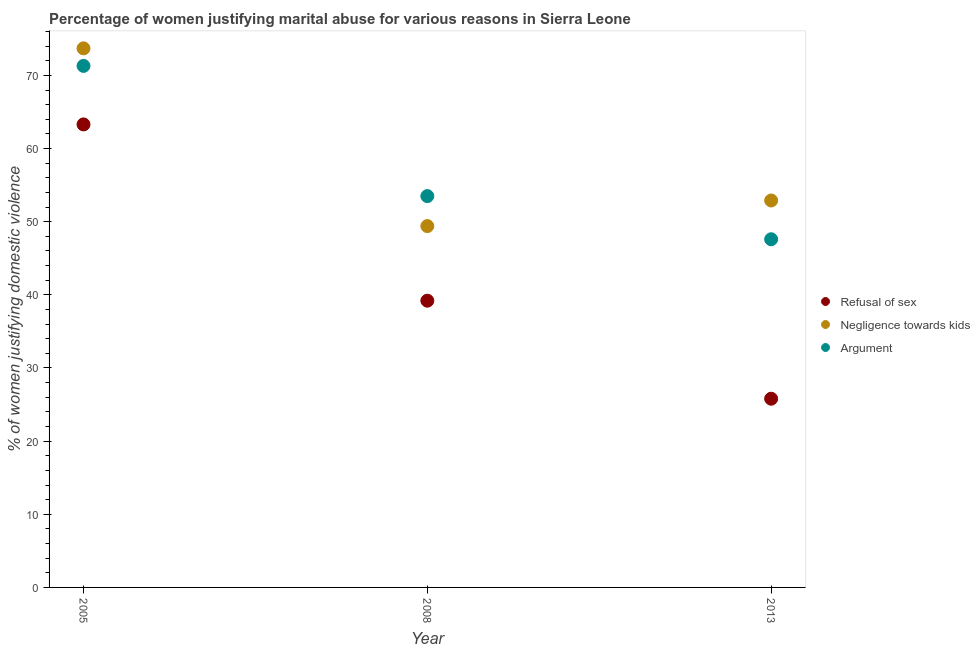How many different coloured dotlines are there?
Your response must be concise. 3. What is the percentage of women justifying domestic violence due to negligence towards kids in 2008?
Your answer should be very brief. 49.4. Across all years, what is the maximum percentage of women justifying domestic violence due to arguments?
Your answer should be very brief. 71.3. Across all years, what is the minimum percentage of women justifying domestic violence due to negligence towards kids?
Provide a succinct answer. 49.4. What is the total percentage of women justifying domestic violence due to negligence towards kids in the graph?
Your response must be concise. 176. What is the difference between the percentage of women justifying domestic violence due to refusal of sex in 2005 and that in 2013?
Your answer should be very brief. 37.5. What is the difference between the percentage of women justifying domestic violence due to negligence towards kids in 2013 and the percentage of women justifying domestic violence due to arguments in 2008?
Offer a terse response. -0.6. What is the average percentage of women justifying domestic violence due to arguments per year?
Keep it short and to the point. 57.47. In the year 2008, what is the difference between the percentage of women justifying domestic violence due to refusal of sex and percentage of women justifying domestic violence due to arguments?
Ensure brevity in your answer.  -14.3. What is the ratio of the percentage of women justifying domestic violence due to refusal of sex in 2005 to that in 2013?
Offer a terse response. 2.45. Is the percentage of women justifying domestic violence due to refusal of sex in 2005 less than that in 2013?
Your answer should be compact. No. What is the difference between the highest and the second highest percentage of women justifying domestic violence due to negligence towards kids?
Give a very brief answer. 20.8. What is the difference between the highest and the lowest percentage of women justifying domestic violence due to negligence towards kids?
Give a very brief answer. 24.3. In how many years, is the percentage of women justifying domestic violence due to negligence towards kids greater than the average percentage of women justifying domestic violence due to negligence towards kids taken over all years?
Keep it short and to the point. 1. Is the sum of the percentage of women justifying domestic violence due to arguments in 2005 and 2013 greater than the maximum percentage of women justifying domestic violence due to negligence towards kids across all years?
Your answer should be very brief. Yes. Is it the case that in every year, the sum of the percentage of women justifying domestic violence due to refusal of sex and percentage of women justifying domestic violence due to negligence towards kids is greater than the percentage of women justifying domestic violence due to arguments?
Offer a very short reply. Yes. Is the percentage of women justifying domestic violence due to refusal of sex strictly greater than the percentage of women justifying domestic violence due to arguments over the years?
Ensure brevity in your answer.  No. Is the percentage of women justifying domestic violence due to arguments strictly less than the percentage of women justifying domestic violence due to negligence towards kids over the years?
Ensure brevity in your answer.  No. How many dotlines are there?
Offer a terse response. 3. What is the difference between two consecutive major ticks on the Y-axis?
Make the answer very short. 10. Are the values on the major ticks of Y-axis written in scientific E-notation?
Make the answer very short. No. Does the graph contain any zero values?
Keep it short and to the point. No. Does the graph contain grids?
Provide a short and direct response. No. Where does the legend appear in the graph?
Your answer should be compact. Center right. How are the legend labels stacked?
Keep it short and to the point. Vertical. What is the title of the graph?
Your answer should be very brief. Percentage of women justifying marital abuse for various reasons in Sierra Leone. Does "Taxes on income" appear as one of the legend labels in the graph?
Provide a succinct answer. No. What is the label or title of the X-axis?
Offer a very short reply. Year. What is the label or title of the Y-axis?
Give a very brief answer. % of women justifying domestic violence. What is the % of women justifying domestic violence in Refusal of sex in 2005?
Provide a succinct answer. 63.3. What is the % of women justifying domestic violence of Negligence towards kids in 2005?
Your answer should be compact. 73.7. What is the % of women justifying domestic violence of Argument in 2005?
Your response must be concise. 71.3. What is the % of women justifying domestic violence in Refusal of sex in 2008?
Your response must be concise. 39.2. What is the % of women justifying domestic violence in Negligence towards kids in 2008?
Offer a terse response. 49.4. What is the % of women justifying domestic violence of Argument in 2008?
Offer a very short reply. 53.5. What is the % of women justifying domestic violence in Refusal of sex in 2013?
Make the answer very short. 25.8. What is the % of women justifying domestic violence of Negligence towards kids in 2013?
Keep it short and to the point. 52.9. What is the % of women justifying domestic violence of Argument in 2013?
Ensure brevity in your answer.  47.6. Across all years, what is the maximum % of women justifying domestic violence in Refusal of sex?
Your answer should be very brief. 63.3. Across all years, what is the maximum % of women justifying domestic violence in Negligence towards kids?
Keep it short and to the point. 73.7. Across all years, what is the maximum % of women justifying domestic violence in Argument?
Make the answer very short. 71.3. Across all years, what is the minimum % of women justifying domestic violence in Refusal of sex?
Offer a terse response. 25.8. Across all years, what is the minimum % of women justifying domestic violence in Negligence towards kids?
Your response must be concise. 49.4. Across all years, what is the minimum % of women justifying domestic violence of Argument?
Provide a short and direct response. 47.6. What is the total % of women justifying domestic violence of Refusal of sex in the graph?
Your answer should be compact. 128.3. What is the total % of women justifying domestic violence in Negligence towards kids in the graph?
Provide a short and direct response. 176. What is the total % of women justifying domestic violence of Argument in the graph?
Offer a terse response. 172.4. What is the difference between the % of women justifying domestic violence of Refusal of sex in 2005 and that in 2008?
Give a very brief answer. 24.1. What is the difference between the % of women justifying domestic violence in Negligence towards kids in 2005 and that in 2008?
Make the answer very short. 24.3. What is the difference between the % of women justifying domestic violence of Refusal of sex in 2005 and that in 2013?
Give a very brief answer. 37.5. What is the difference between the % of women justifying domestic violence in Negligence towards kids in 2005 and that in 2013?
Offer a very short reply. 20.8. What is the difference between the % of women justifying domestic violence in Argument in 2005 and that in 2013?
Give a very brief answer. 23.7. What is the difference between the % of women justifying domestic violence of Refusal of sex in 2008 and that in 2013?
Your answer should be very brief. 13.4. What is the difference between the % of women justifying domestic violence in Argument in 2008 and that in 2013?
Keep it short and to the point. 5.9. What is the difference between the % of women justifying domestic violence in Refusal of sex in 2005 and the % of women justifying domestic violence in Argument in 2008?
Your answer should be very brief. 9.8. What is the difference between the % of women justifying domestic violence of Negligence towards kids in 2005 and the % of women justifying domestic violence of Argument in 2008?
Your answer should be compact. 20.2. What is the difference between the % of women justifying domestic violence in Refusal of sex in 2005 and the % of women justifying domestic violence in Argument in 2013?
Keep it short and to the point. 15.7. What is the difference between the % of women justifying domestic violence of Negligence towards kids in 2005 and the % of women justifying domestic violence of Argument in 2013?
Provide a succinct answer. 26.1. What is the difference between the % of women justifying domestic violence of Refusal of sex in 2008 and the % of women justifying domestic violence of Negligence towards kids in 2013?
Your answer should be compact. -13.7. What is the average % of women justifying domestic violence of Refusal of sex per year?
Provide a succinct answer. 42.77. What is the average % of women justifying domestic violence of Negligence towards kids per year?
Provide a short and direct response. 58.67. What is the average % of women justifying domestic violence in Argument per year?
Offer a terse response. 57.47. In the year 2005, what is the difference between the % of women justifying domestic violence in Refusal of sex and % of women justifying domestic violence in Negligence towards kids?
Make the answer very short. -10.4. In the year 2005, what is the difference between the % of women justifying domestic violence of Refusal of sex and % of women justifying domestic violence of Argument?
Offer a terse response. -8. In the year 2008, what is the difference between the % of women justifying domestic violence of Refusal of sex and % of women justifying domestic violence of Negligence towards kids?
Offer a very short reply. -10.2. In the year 2008, what is the difference between the % of women justifying domestic violence in Refusal of sex and % of women justifying domestic violence in Argument?
Offer a very short reply. -14.3. In the year 2013, what is the difference between the % of women justifying domestic violence in Refusal of sex and % of women justifying domestic violence in Negligence towards kids?
Ensure brevity in your answer.  -27.1. In the year 2013, what is the difference between the % of women justifying domestic violence of Refusal of sex and % of women justifying domestic violence of Argument?
Offer a very short reply. -21.8. In the year 2013, what is the difference between the % of women justifying domestic violence in Negligence towards kids and % of women justifying domestic violence in Argument?
Make the answer very short. 5.3. What is the ratio of the % of women justifying domestic violence in Refusal of sex in 2005 to that in 2008?
Your answer should be very brief. 1.61. What is the ratio of the % of women justifying domestic violence in Negligence towards kids in 2005 to that in 2008?
Offer a terse response. 1.49. What is the ratio of the % of women justifying domestic violence in Argument in 2005 to that in 2008?
Give a very brief answer. 1.33. What is the ratio of the % of women justifying domestic violence of Refusal of sex in 2005 to that in 2013?
Provide a succinct answer. 2.45. What is the ratio of the % of women justifying domestic violence of Negligence towards kids in 2005 to that in 2013?
Your answer should be very brief. 1.39. What is the ratio of the % of women justifying domestic violence in Argument in 2005 to that in 2013?
Ensure brevity in your answer.  1.5. What is the ratio of the % of women justifying domestic violence of Refusal of sex in 2008 to that in 2013?
Provide a short and direct response. 1.52. What is the ratio of the % of women justifying domestic violence in Negligence towards kids in 2008 to that in 2013?
Offer a very short reply. 0.93. What is the ratio of the % of women justifying domestic violence in Argument in 2008 to that in 2013?
Your answer should be compact. 1.12. What is the difference between the highest and the second highest % of women justifying domestic violence in Refusal of sex?
Your answer should be compact. 24.1. What is the difference between the highest and the second highest % of women justifying domestic violence in Negligence towards kids?
Provide a succinct answer. 20.8. What is the difference between the highest and the lowest % of women justifying domestic violence in Refusal of sex?
Your answer should be very brief. 37.5. What is the difference between the highest and the lowest % of women justifying domestic violence in Negligence towards kids?
Provide a short and direct response. 24.3. What is the difference between the highest and the lowest % of women justifying domestic violence of Argument?
Make the answer very short. 23.7. 